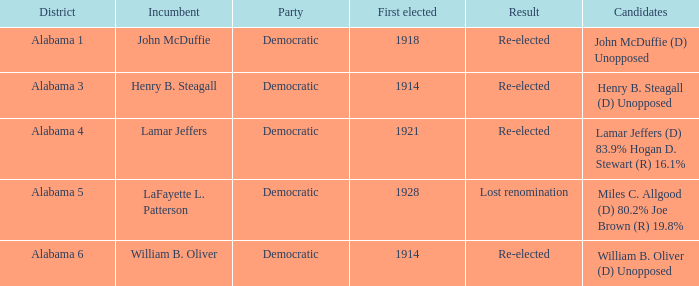How many in total were elected first in lost renomination? 1.0. 